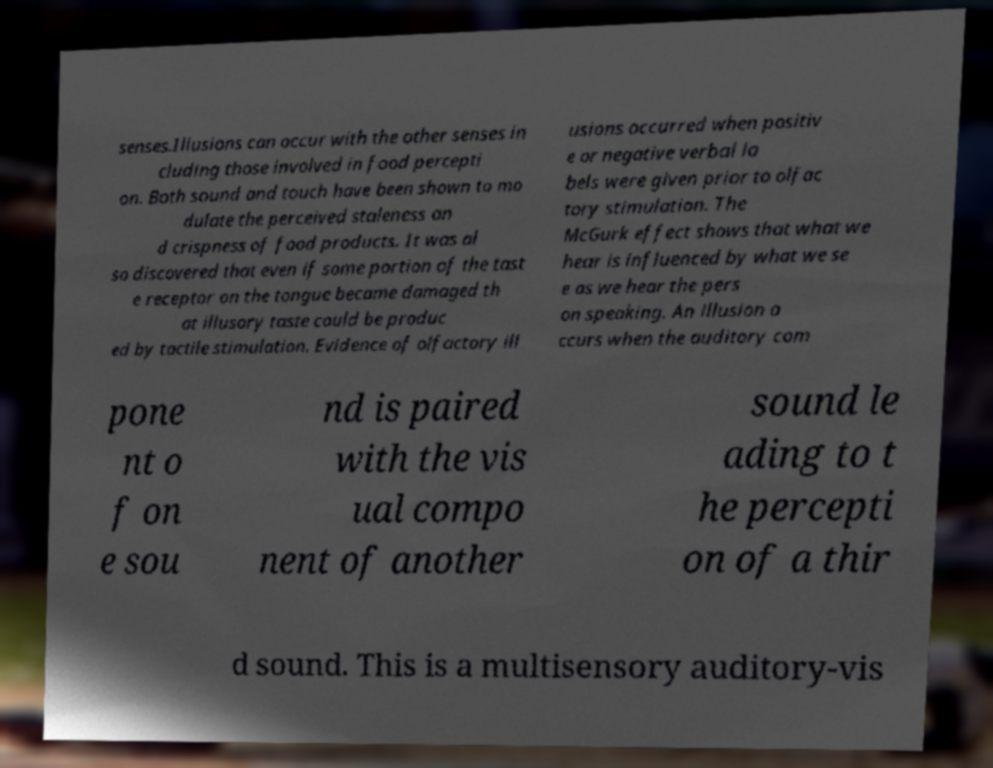What messages or text are displayed in this image? I need them in a readable, typed format. senses.Illusions can occur with the other senses in cluding those involved in food percepti on. Both sound and touch have been shown to mo dulate the perceived staleness an d crispness of food products. It was al so discovered that even if some portion of the tast e receptor on the tongue became damaged th at illusory taste could be produc ed by tactile stimulation. Evidence of olfactory ill usions occurred when positiv e or negative verbal la bels were given prior to olfac tory stimulation. The McGurk effect shows that what we hear is influenced by what we se e as we hear the pers on speaking. An illusion o ccurs when the auditory com pone nt o f on e sou nd is paired with the vis ual compo nent of another sound le ading to t he percepti on of a thir d sound. This is a multisensory auditory-vis 